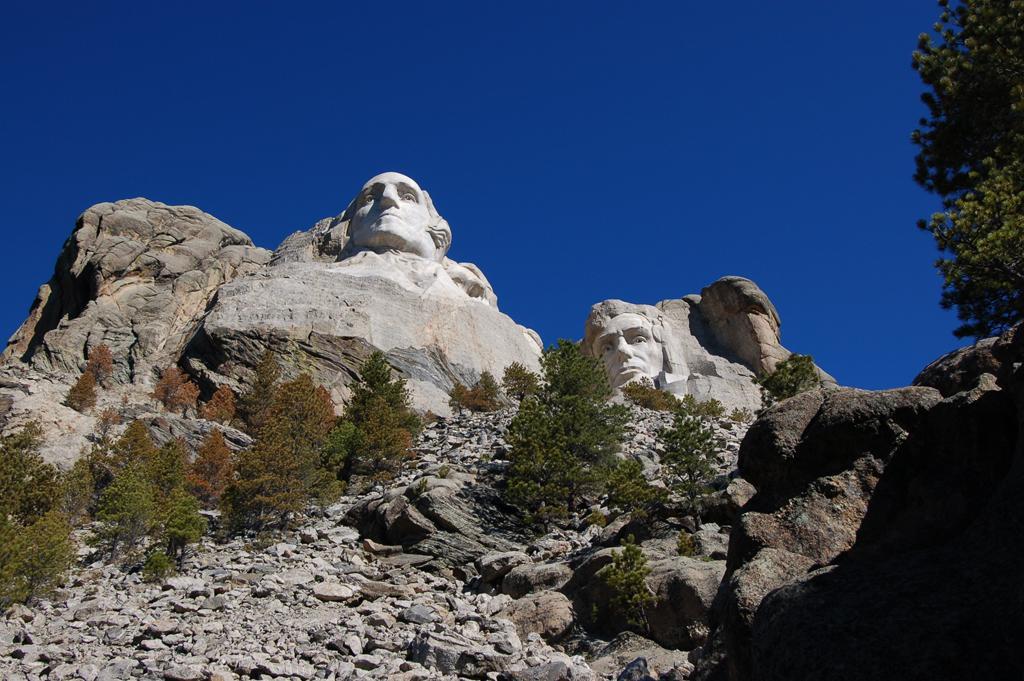Please provide a concise description of this image. In the image we can see stone sculptures. These are the stones, big rock, trees and a blue sky. 